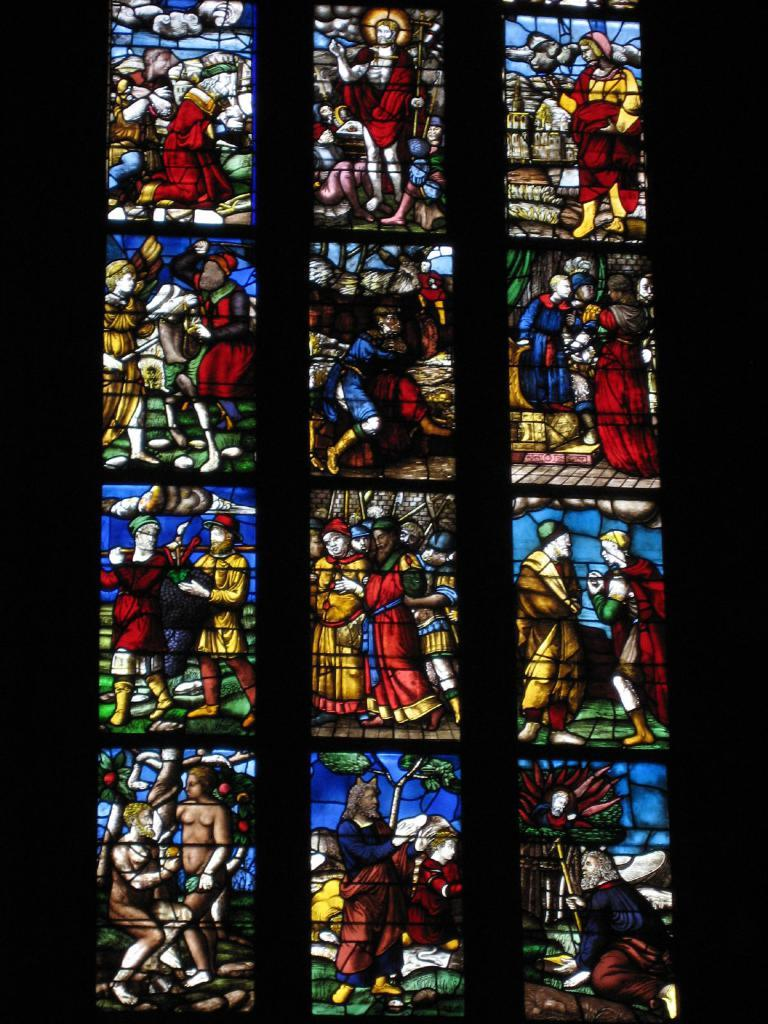What type of window is visible in the image? There is a glass window in the image. What is unique about the glass window? The glass window has a painting on it. What can be seen in the painting on the glass window? The painting depicts a few persons. Can you see any cheese in the image? There is no cheese present in the image. How does the rat interact with the painting on the glass window? There is no rat present in the image, so it cannot interact with the painting. 